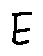Convert formula to latex. <formula><loc_0><loc_0><loc_500><loc_500>E</formula> 